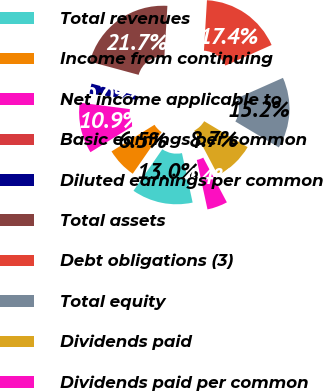Convert chart. <chart><loc_0><loc_0><loc_500><loc_500><pie_chart><fcel>Total revenues<fcel>Income from continuing<fcel>Net income applicable to<fcel>Basic earnings per common<fcel>Diluted earnings per common<fcel>Total assets<fcel>Debt obligations (3)<fcel>Total equity<fcel>Dividends paid<fcel>Dividends paid per common<nl><fcel>13.04%<fcel>6.52%<fcel>10.87%<fcel>0.0%<fcel>2.17%<fcel>21.74%<fcel>17.39%<fcel>15.22%<fcel>8.7%<fcel>4.35%<nl></chart> 